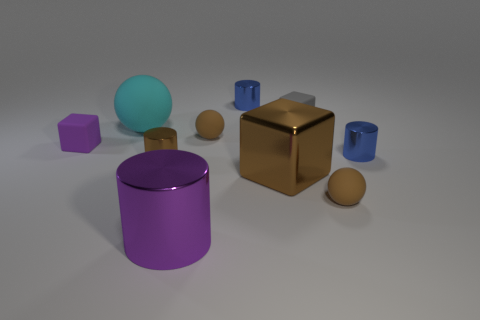The other block that is the same size as the gray block is what color?
Your answer should be compact. Purple. There is a big cyan object; is its shape the same as the brown metallic thing on the right side of the purple metal thing?
Offer a terse response. No. What is the shape of the tiny shiny thing that is the same color as the shiny cube?
Provide a succinct answer. Cylinder. How many purple shiny cylinders are left of the tiny shiny thing in front of the blue metallic thing that is in front of the big cyan rubber object?
Your answer should be very brief. 0. There is a brown metal cube that is in front of the small blue metal cylinder that is right of the gray rubber thing; what is its size?
Offer a terse response. Large. What size is the cyan sphere that is the same material as the tiny gray object?
Provide a succinct answer. Large. What shape is the small thing that is both to the left of the large metallic cylinder and to the right of the cyan thing?
Provide a short and direct response. Cylinder. Are there an equal number of tiny shiny cylinders that are right of the large cylinder and cyan balls?
Your answer should be compact. No. How many things are either tiny matte things or blue metal cylinders that are in front of the small purple thing?
Ensure brevity in your answer.  5. Are there any tiny blue things of the same shape as the large brown shiny object?
Give a very brief answer. No. 